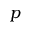<formula> <loc_0><loc_0><loc_500><loc_500>p</formula> 